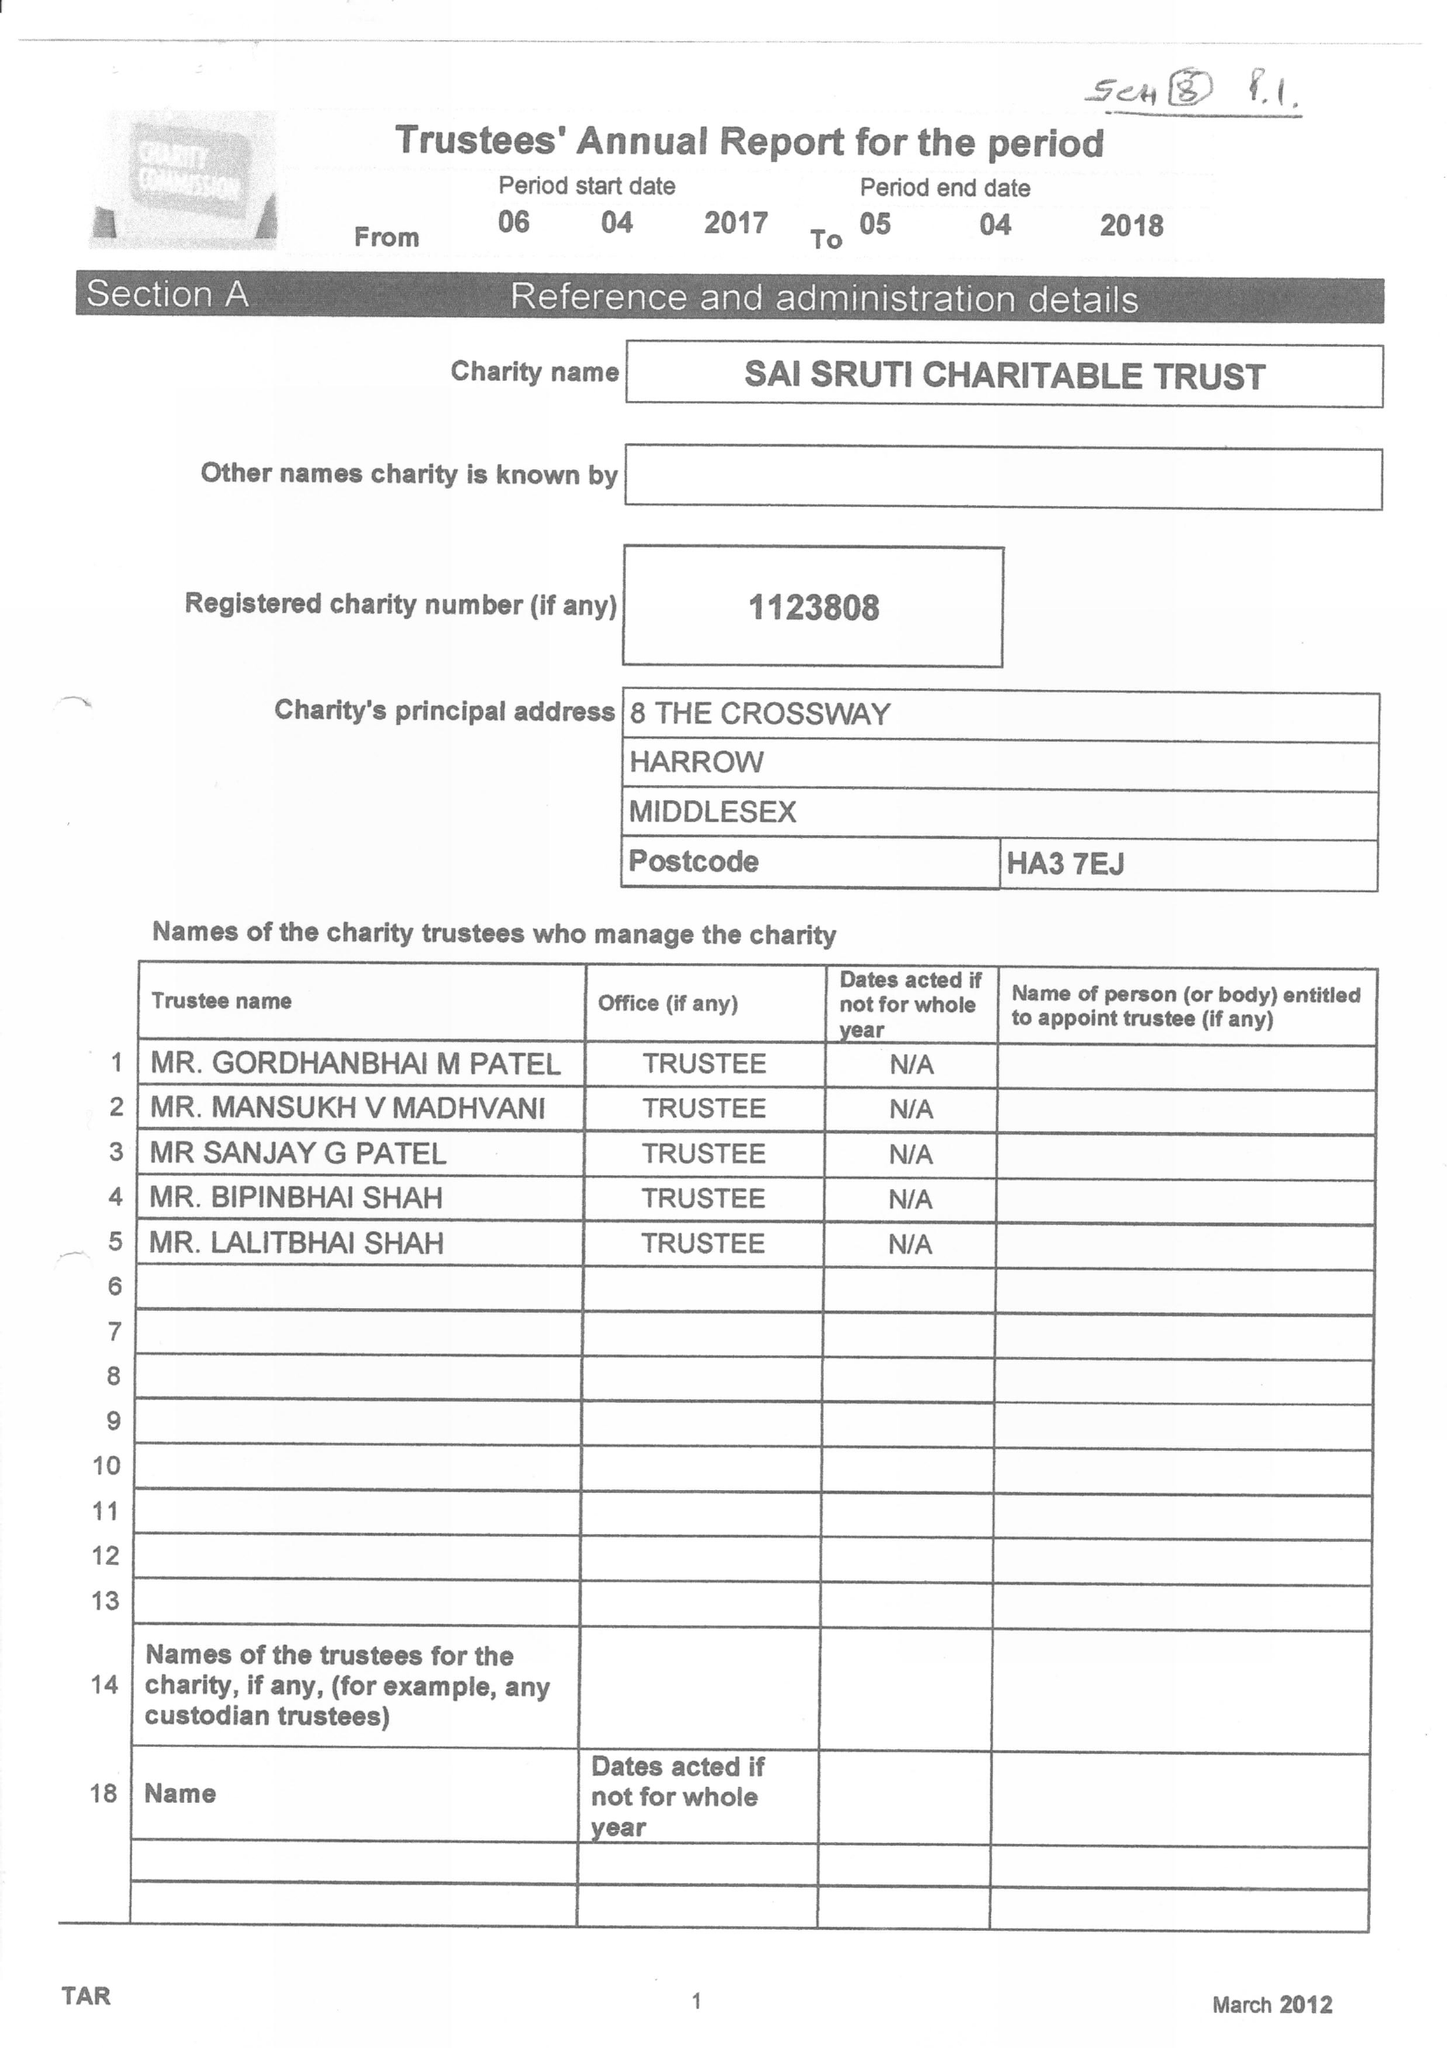What is the value for the charity_number?
Answer the question using a single word or phrase. 1123808 